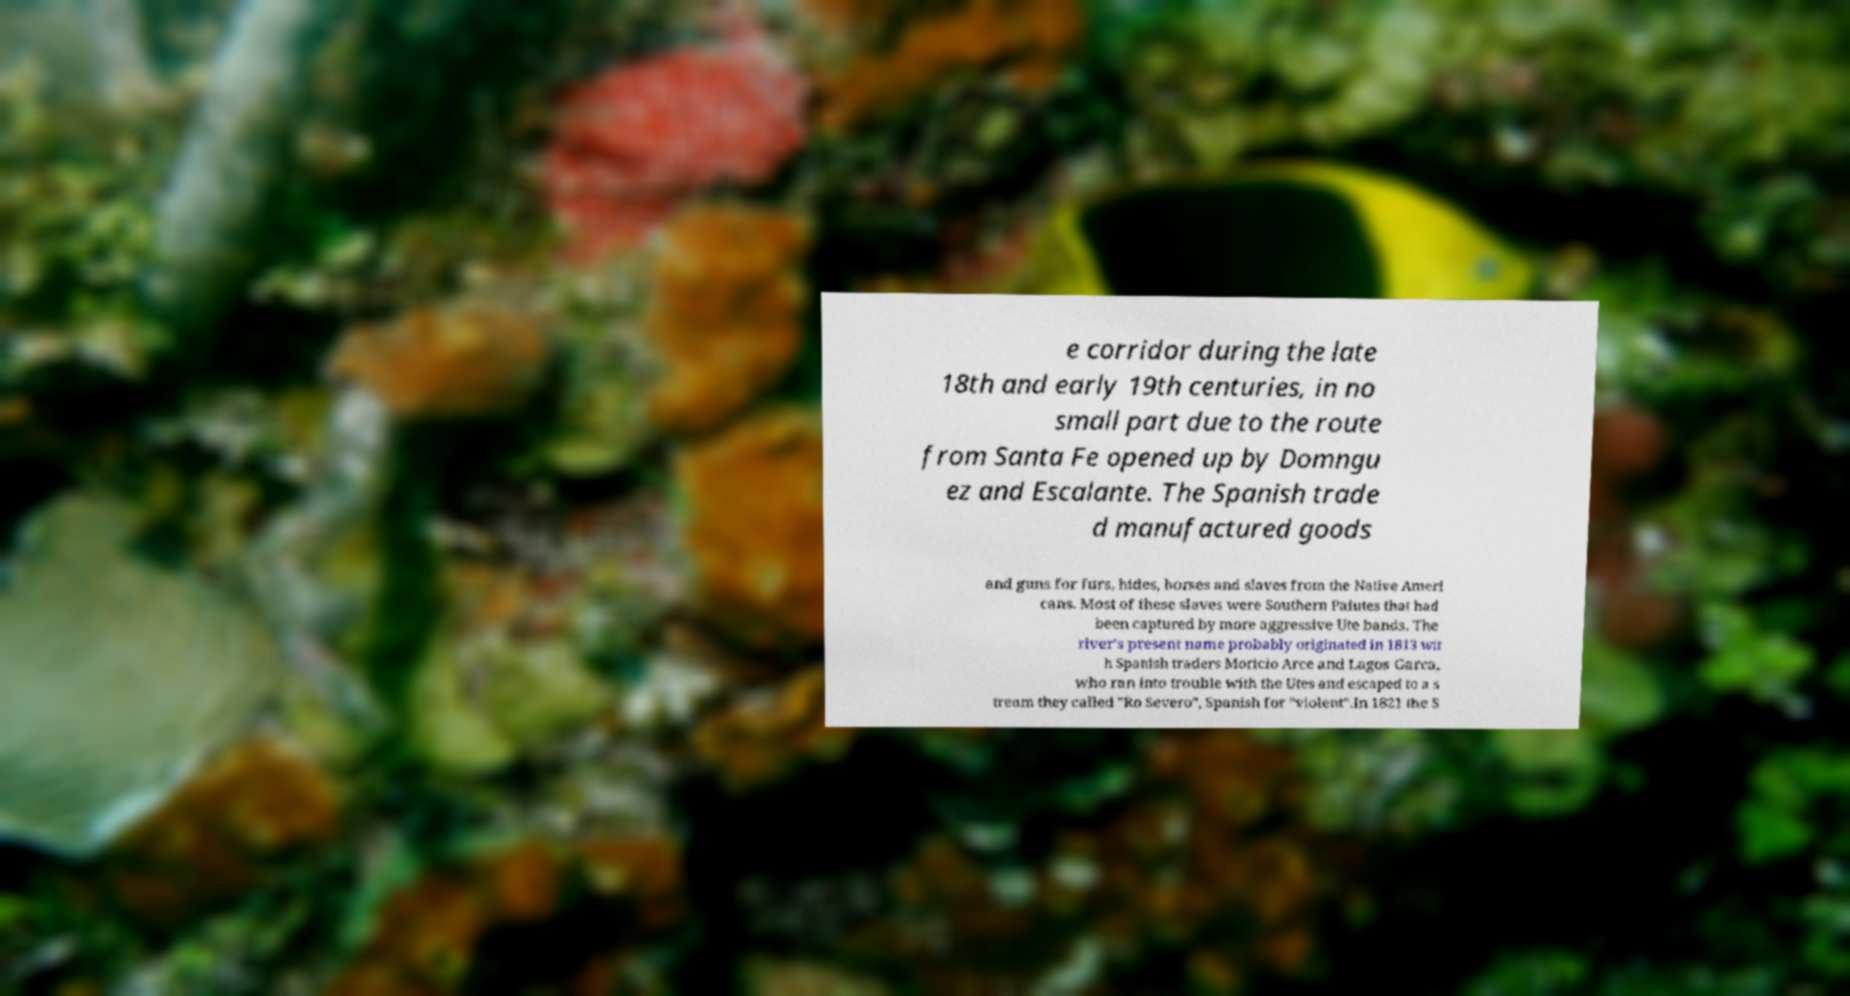Could you extract and type out the text from this image? e corridor during the late 18th and early 19th centuries, in no small part due to the route from Santa Fe opened up by Domngu ez and Escalante. The Spanish trade d manufactured goods and guns for furs, hides, horses and slaves from the Native Ameri cans. Most of these slaves were Southern Paiutes that had been captured by more aggressive Ute bands. The river's present name probably originated in 1813 wit h Spanish traders Moricio Arce and Lagos Garca, who ran into trouble with the Utes and escaped to a s tream they called "Ro Severo", Spanish for "violent".In 1821 the S 